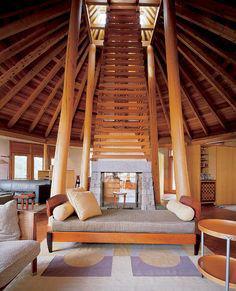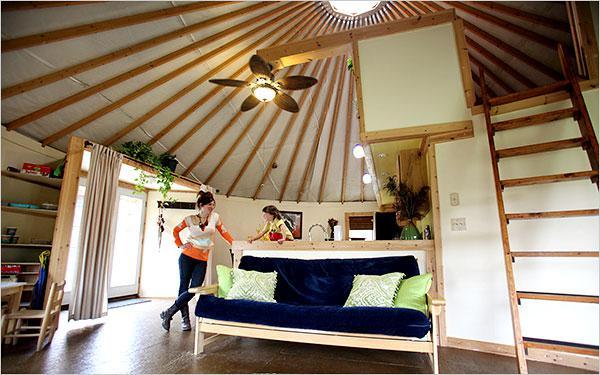The first image is the image on the left, the second image is the image on the right. Examine the images to the left and right. Is the description "There is exactly one ceiling fan in the image on the right." accurate? Answer yes or no. Yes. 